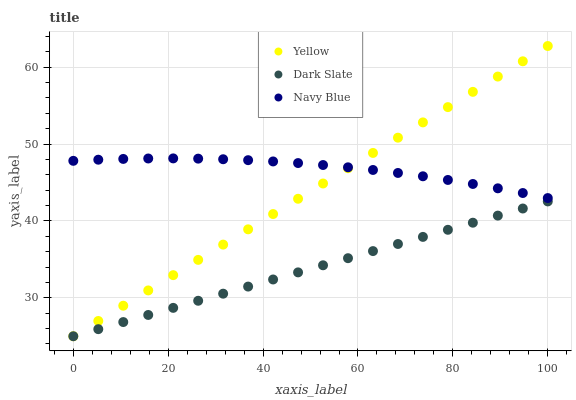Does Dark Slate have the minimum area under the curve?
Answer yes or no. Yes. Does Navy Blue have the maximum area under the curve?
Answer yes or no. Yes. Does Yellow have the minimum area under the curve?
Answer yes or no. No. Does Yellow have the maximum area under the curve?
Answer yes or no. No. Is Dark Slate the smoothest?
Answer yes or no. Yes. Is Navy Blue the roughest?
Answer yes or no. Yes. Is Yellow the smoothest?
Answer yes or no. No. Is Yellow the roughest?
Answer yes or no. No. Does Dark Slate have the lowest value?
Answer yes or no. Yes. Does Navy Blue have the lowest value?
Answer yes or no. No. Does Yellow have the highest value?
Answer yes or no. Yes. Does Navy Blue have the highest value?
Answer yes or no. No. Is Dark Slate less than Navy Blue?
Answer yes or no. Yes. Is Navy Blue greater than Dark Slate?
Answer yes or no. Yes. Does Dark Slate intersect Yellow?
Answer yes or no. Yes. Is Dark Slate less than Yellow?
Answer yes or no. No. Is Dark Slate greater than Yellow?
Answer yes or no. No. Does Dark Slate intersect Navy Blue?
Answer yes or no. No. 